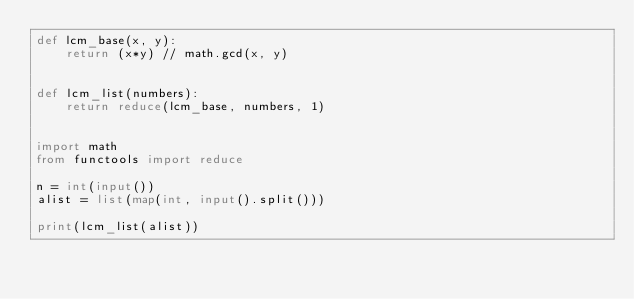<code> <loc_0><loc_0><loc_500><loc_500><_Python_>def lcm_base(x, y):
    return (x*y) // math.gcd(x, y)


def lcm_list(numbers):
    return reduce(lcm_base, numbers, 1)


import math
from functools import reduce

n = int(input())
alist = list(map(int, input().split()))

print(lcm_list(alist))
</code> 